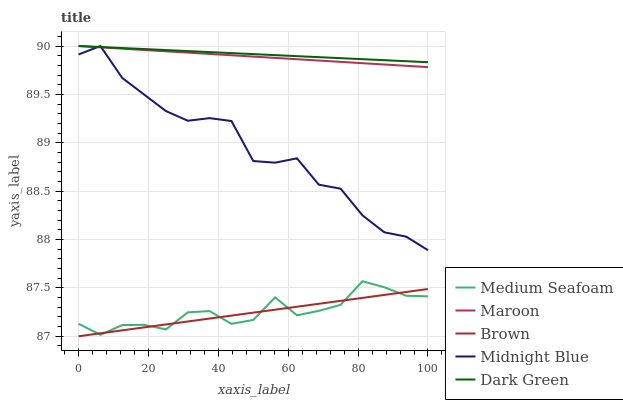Does Medium Seafoam have the minimum area under the curve?
Answer yes or no. No. Does Medium Seafoam have the maximum area under the curve?
Answer yes or no. No. Is Dark Green the smoothest?
Answer yes or no. No. Is Dark Green the roughest?
Answer yes or no. No. Does Medium Seafoam have the lowest value?
Answer yes or no. No. Does Medium Seafoam have the highest value?
Answer yes or no. No. Is Brown less than Maroon?
Answer yes or no. Yes. Is Dark Green greater than Brown?
Answer yes or no. Yes. Does Brown intersect Maroon?
Answer yes or no. No. 